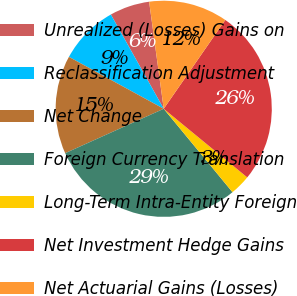<chart> <loc_0><loc_0><loc_500><loc_500><pie_chart><fcel>Unrealized (Losses) Gains on<fcel>Reclassification Adjustment<fcel>Net Change<fcel>Foreign Currency Translation<fcel>Long-Term Intra-Entity Foreign<fcel>Net Investment Hedge Gains<fcel>Net Actuarial Gains (Losses)<nl><fcel>5.98%<fcel>8.89%<fcel>14.71%<fcel>29.24%<fcel>3.08%<fcel>26.3%<fcel>11.8%<nl></chart> 